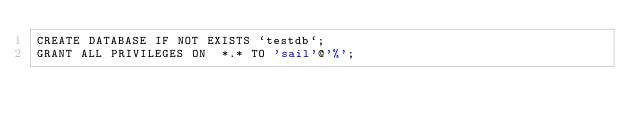<code> <loc_0><loc_0><loc_500><loc_500><_SQL_>CREATE DATABASE IF NOT EXISTS `testdb`;
GRANT ALL PRIVILEGES ON  *.* TO 'sail'@'%';
</code> 